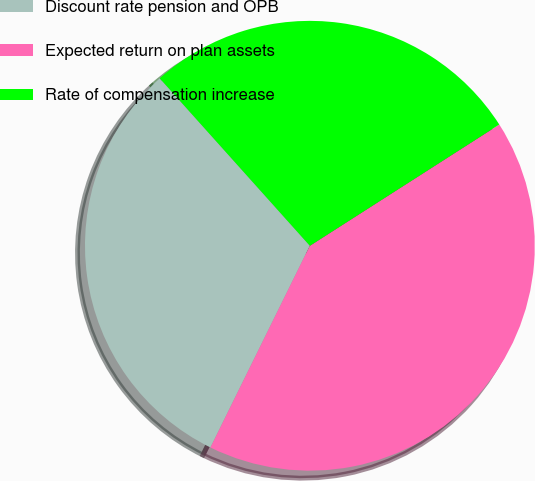Convert chart. <chart><loc_0><loc_0><loc_500><loc_500><pie_chart><fcel>Discount rate pension and OPB<fcel>Expected return on plan assets<fcel>Rate of compensation increase<nl><fcel>31.08%<fcel>41.35%<fcel>27.57%<nl></chart> 